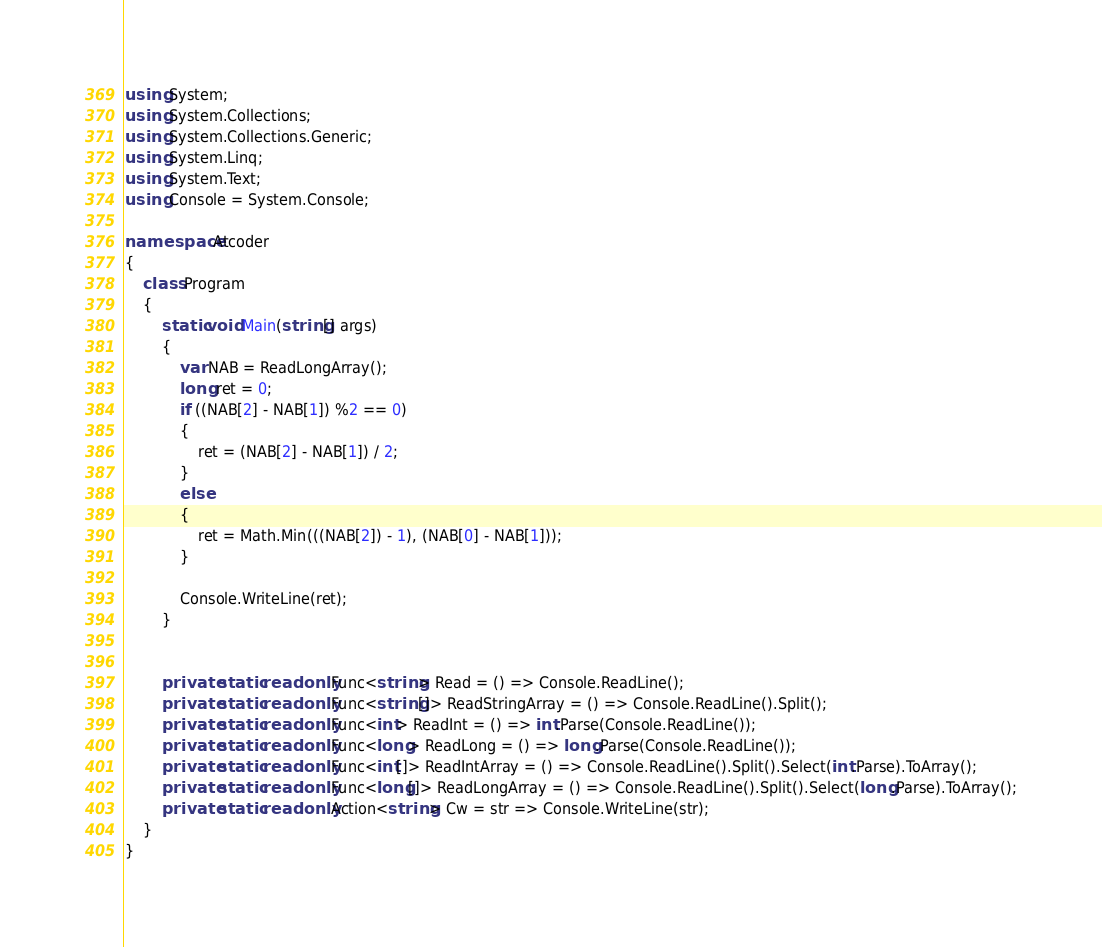<code> <loc_0><loc_0><loc_500><loc_500><_C#_>using System;
using System.Collections;
using System.Collections.Generic;
using System.Linq;
using System.Text;
using Console = System.Console;

namespace Atcoder
{
    class Program
    {
        static void Main(string[] args)
        {
            var NAB = ReadLongArray();
            long ret = 0;
            if ((NAB[2] - NAB[1]) %2 == 0)
            {
                ret = (NAB[2] - NAB[1]) / 2;
            }
            else
            {
                ret = Math.Min(((NAB[2]) - 1), (NAB[0] - NAB[1]));
            }

            Console.WriteLine(ret);
        }


        private static readonly Func<string> Read = () => Console.ReadLine();
        private static readonly Func<string[]> ReadStringArray = () => Console.ReadLine().Split();
        private static readonly Func<int> ReadInt = () => int.Parse(Console.ReadLine());
        private static readonly Func<long> ReadLong = () => long.Parse(Console.ReadLine());
        private static readonly Func<int[]> ReadIntArray = () => Console.ReadLine().Split().Select(int.Parse).ToArray();
        private static readonly Func<long[]> ReadLongArray = () => Console.ReadLine().Split().Select(long.Parse).ToArray();
        private static readonly Action<string> Cw = str => Console.WriteLine(str);
    }
}</code> 